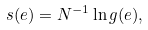Convert formula to latex. <formula><loc_0><loc_0><loc_500><loc_500>s ( e ) = N ^ { - 1 } \ln g ( e ) ,</formula> 